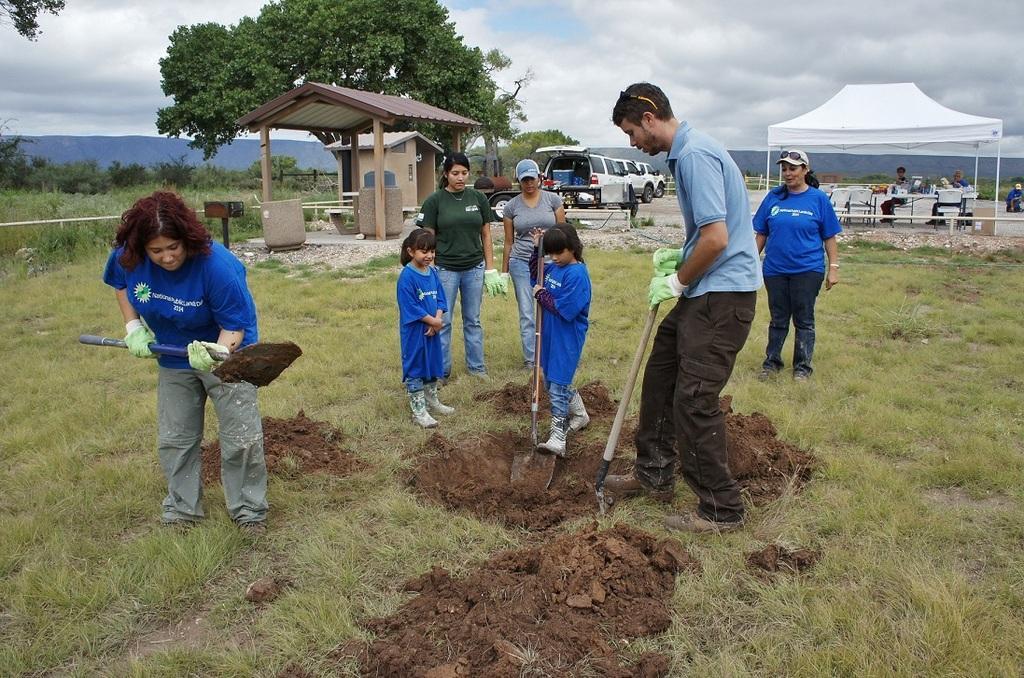Describe this image in one or two sentences. In this image I can see the group of people with blue, ash and green color dresses. I can see few people are holding the mud diggers. In the background I can see the tent, sheds and vehicles. I can see few people are sitting under the tent. I can also see many trees, mountain, clouds and the sky. 